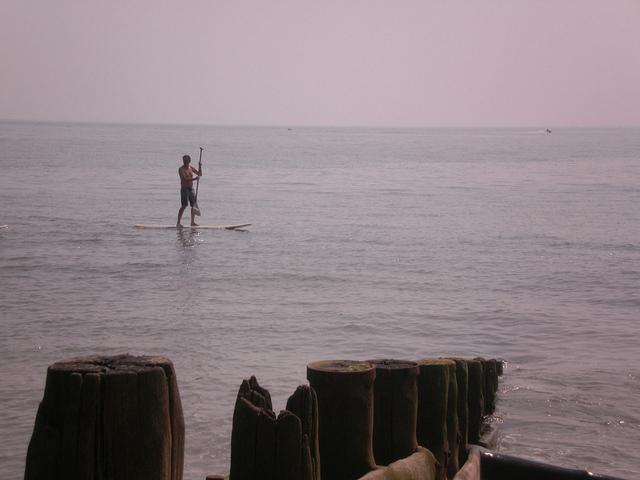Where else would his hand held tool be somewhat suitable?
Select the accurate response from the four choices given to answer the question.
Options: Dining room, kitchen, math class, boat. Boat. 